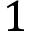<formula> <loc_0><loc_0><loc_500><loc_500>1</formula> 